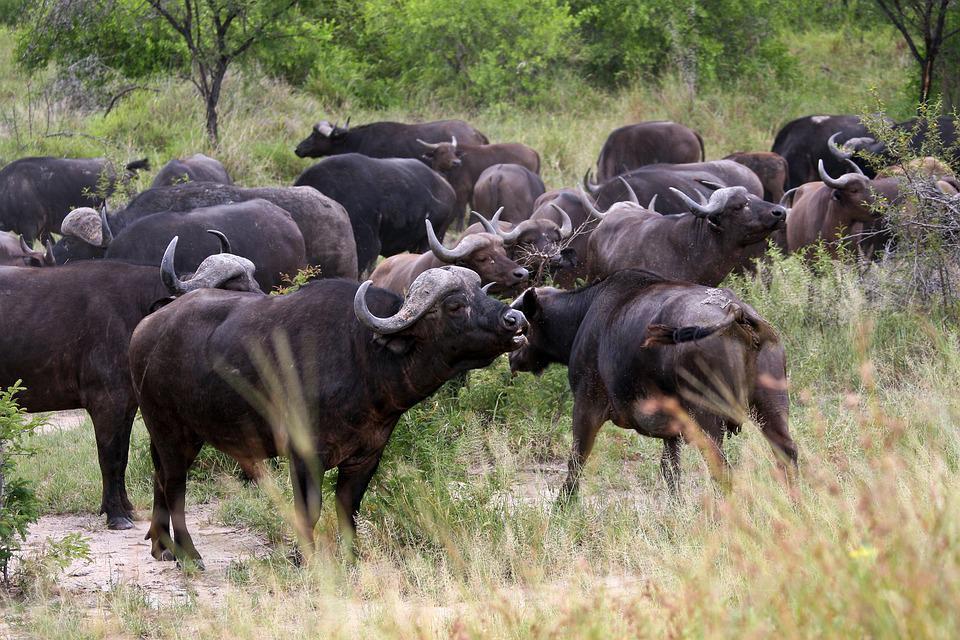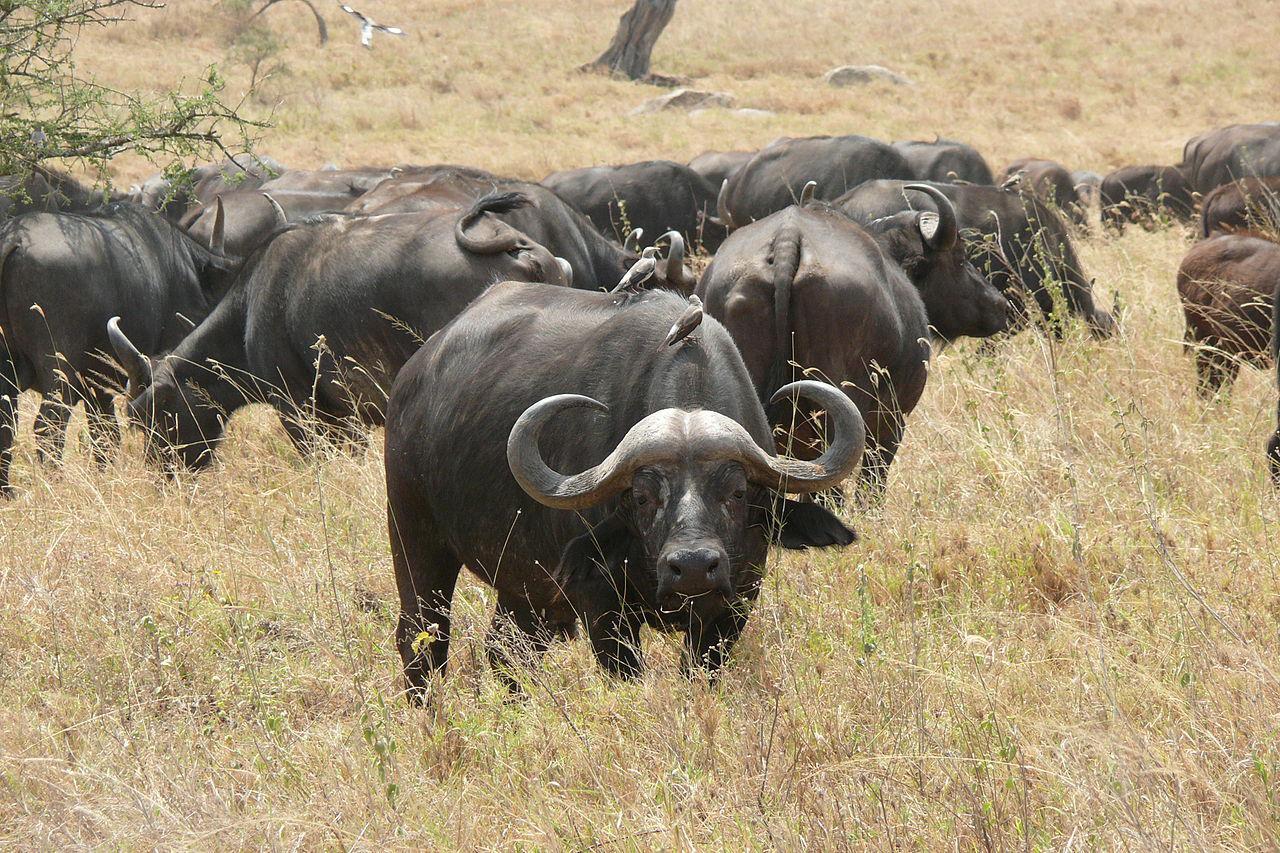The first image is the image on the left, the second image is the image on the right. For the images displayed, is the sentence "All water buffalo are standing, and no water buffalo are in a scene with other types of mammals." factually correct? Answer yes or no. Yes. The first image is the image on the left, the second image is the image on the right. For the images shown, is this caption "There is at least one white bird in the right image." true? Answer yes or no. Yes. 